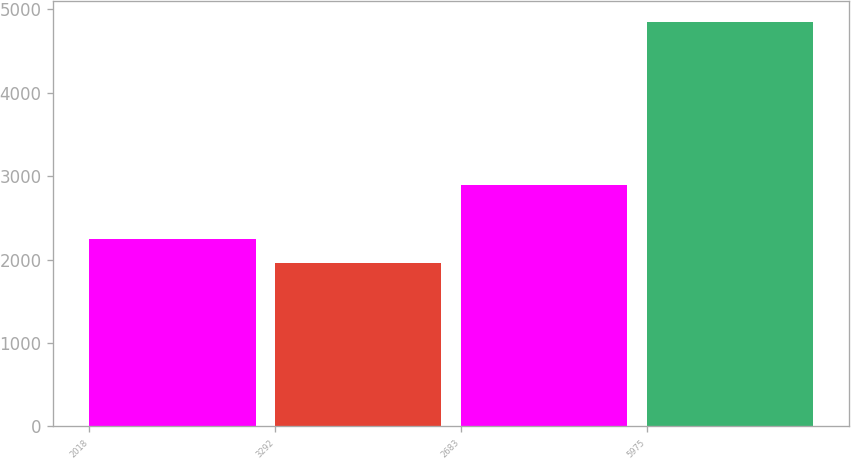Convert chart. <chart><loc_0><loc_0><loc_500><loc_500><bar_chart><fcel>2018<fcel>3292<fcel>2683<fcel>5975<nl><fcel>2243<fcel>1953<fcel>2900<fcel>4853<nl></chart> 